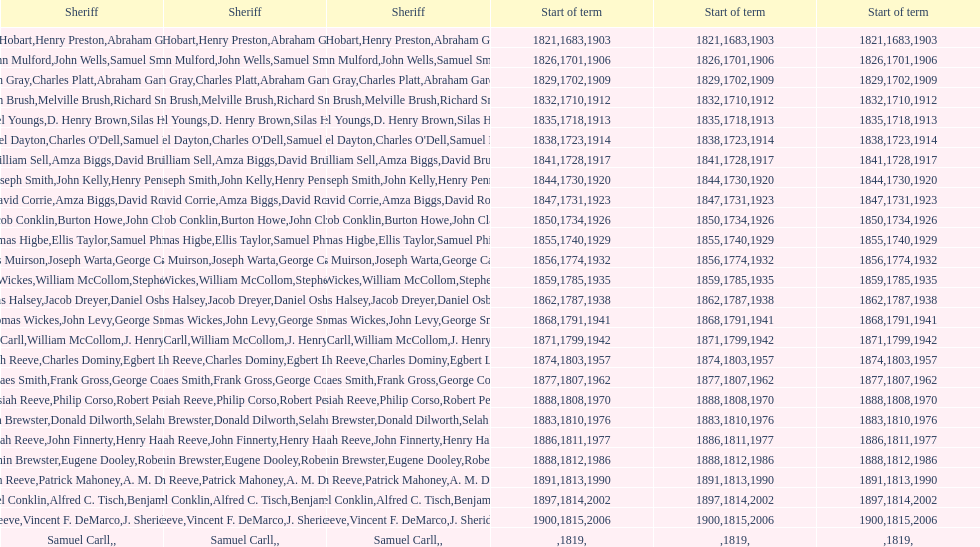How sheriffs has suffolk county had in total? 76. 